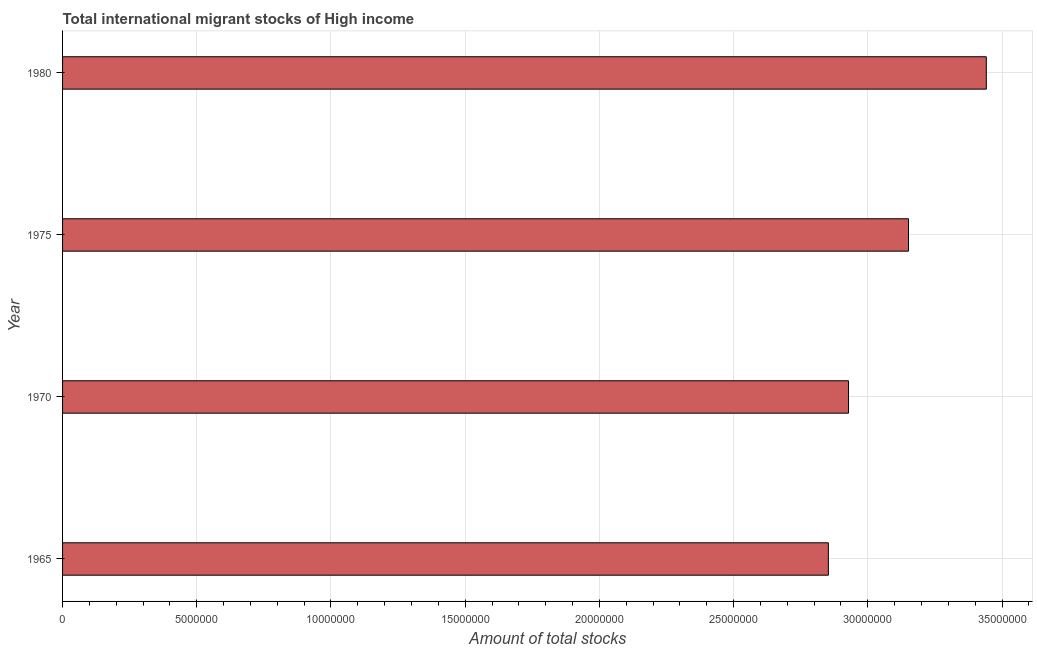Does the graph contain any zero values?
Your answer should be very brief. No. Does the graph contain grids?
Keep it short and to the point. Yes. What is the title of the graph?
Provide a short and direct response. Total international migrant stocks of High income. What is the label or title of the X-axis?
Offer a very short reply. Amount of total stocks. What is the label or title of the Y-axis?
Your response must be concise. Year. What is the total number of international migrant stock in 1970?
Provide a succinct answer. 2.93e+07. Across all years, what is the maximum total number of international migrant stock?
Offer a very short reply. 3.44e+07. Across all years, what is the minimum total number of international migrant stock?
Provide a succinct answer. 2.85e+07. In which year was the total number of international migrant stock maximum?
Your response must be concise. 1980. In which year was the total number of international migrant stock minimum?
Offer a very short reply. 1965. What is the sum of the total number of international migrant stock?
Give a very brief answer. 1.24e+08. What is the difference between the total number of international migrant stock in 1970 and 1980?
Your response must be concise. -5.13e+06. What is the average total number of international migrant stock per year?
Provide a succinct answer. 3.09e+07. What is the median total number of international migrant stock?
Keep it short and to the point. 3.04e+07. In how many years, is the total number of international migrant stock greater than 5000000 ?
Your answer should be very brief. 4. What is the ratio of the total number of international migrant stock in 1965 to that in 1975?
Your response must be concise. 0.91. What is the difference between the highest and the second highest total number of international migrant stock?
Your answer should be very brief. 2.90e+06. Is the sum of the total number of international migrant stock in 1965 and 1975 greater than the maximum total number of international migrant stock across all years?
Your response must be concise. Yes. What is the difference between the highest and the lowest total number of international migrant stock?
Your response must be concise. 5.88e+06. In how many years, is the total number of international migrant stock greater than the average total number of international migrant stock taken over all years?
Your answer should be very brief. 2. How many bars are there?
Your response must be concise. 4. What is the difference between two consecutive major ticks on the X-axis?
Make the answer very short. 5.00e+06. What is the Amount of total stocks in 1965?
Provide a succinct answer. 2.85e+07. What is the Amount of total stocks in 1970?
Provide a succinct answer. 2.93e+07. What is the Amount of total stocks of 1975?
Your answer should be very brief. 3.15e+07. What is the Amount of total stocks in 1980?
Your answer should be very brief. 3.44e+07. What is the difference between the Amount of total stocks in 1965 and 1970?
Keep it short and to the point. -7.52e+05. What is the difference between the Amount of total stocks in 1965 and 1975?
Give a very brief answer. -2.99e+06. What is the difference between the Amount of total stocks in 1965 and 1980?
Your answer should be very brief. -5.88e+06. What is the difference between the Amount of total stocks in 1970 and 1975?
Give a very brief answer. -2.23e+06. What is the difference between the Amount of total stocks in 1970 and 1980?
Make the answer very short. -5.13e+06. What is the difference between the Amount of total stocks in 1975 and 1980?
Offer a very short reply. -2.90e+06. What is the ratio of the Amount of total stocks in 1965 to that in 1970?
Your answer should be very brief. 0.97. What is the ratio of the Amount of total stocks in 1965 to that in 1975?
Provide a succinct answer. 0.91. What is the ratio of the Amount of total stocks in 1965 to that in 1980?
Your answer should be very brief. 0.83. What is the ratio of the Amount of total stocks in 1970 to that in 1975?
Ensure brevity in your answer.  0.93. What is the ratio of the Amount of total stocks in 1970 to that in 1980?
Offer a terse response. 0.85. What is the ratio of the Amount of total stocks in 1975 to that in 1980?
Offer a very short reply. 0.92. 